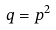<formula> <loc_0><loc_0><loc_500><loc_500>q = p ^ { 2 }</formula> 